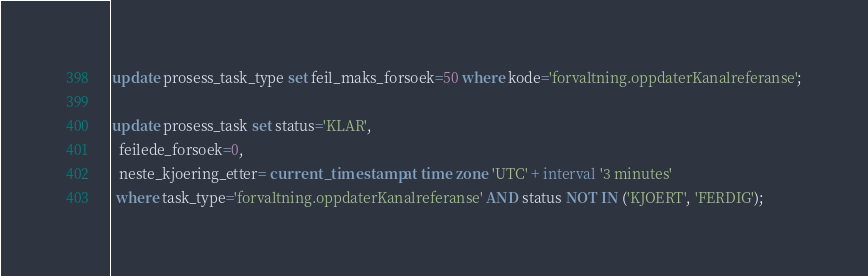Convert code to text. <code><loc_0><loc_0><loc_500><loc_500><_SQL_>update prosess_task_type set feil_maks_forsoek=50 where kode='forvaltning.oppdaterKanalreferanse';

update prosess_task set status='KLAR', 
  feilede_forsoek=0, 
  neste_kjoering_etter= current_timestamp at time zone 'UTC' + interval '3 minutes'
 where task_type='forvaltning.oppdaterKanalreferanse' AND status NOT IN ('KJOERT', 'FERDIG');

</code> 